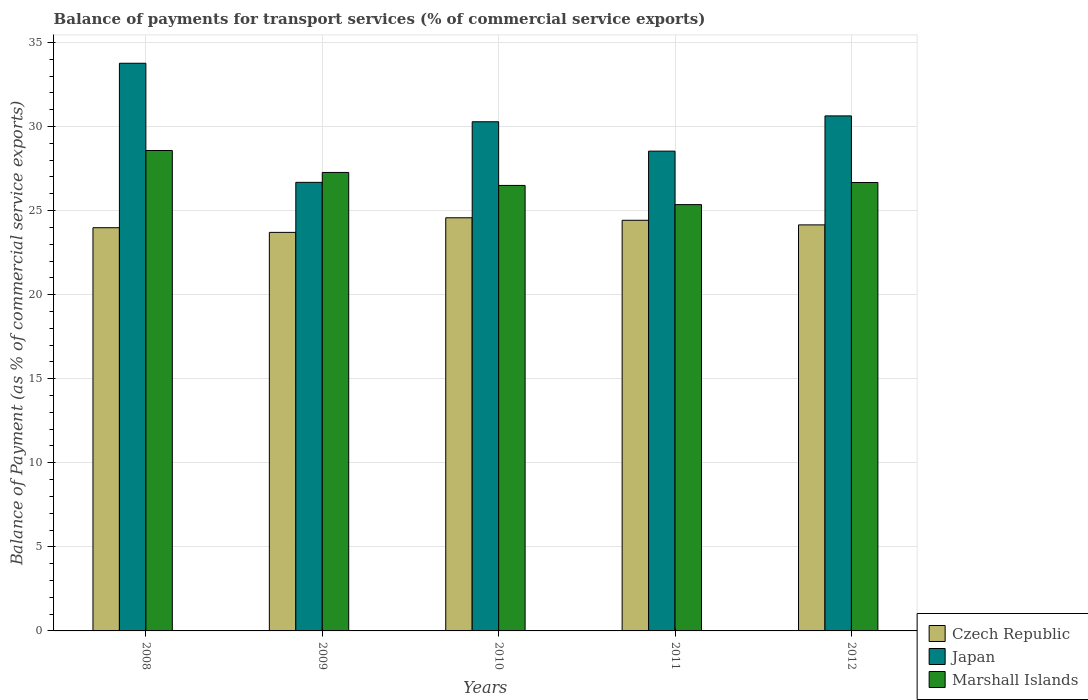How many different coloured bars are there?
Offer a terse response. 3. Are the number of bars per tick equal to the number of legend labels?
Offer a very short reply. Yes. How many bars are there on the 4th tick from the left?
Keep it short and to the point. 3. In how many cases, is the number of bars for a given year not equal to the number of legend labels?
Provide a succinct answer. 0. What is the balance of payments for transport services in Czech Republic in 2011?
Offer a terse response. 24.42. Across all years, what is the maximum balance of payments for transport services in Japan?
Keep it short and to the point. 33.76. Across all years, what is the minimum balance of payments for transport services in Czech Republic?
Provide a short and direct response. 23.7. In which year was the balance of payments for transport services in Marshall Islands maximum?
Offer a terse response. 2008. What is the total balance of payments for transport services in Marshall Islands in the graph?
Your answer should be very brief. 134.36. What is the difference between the balance of payments for transport services in Japan in 2008 and that in 2012?
Keep it short and to the point. 3.13. What is the difference between the balance of payments for transport services in Czech Republic in 2011 and the balance of payments for transport services in Marshall Islands in 2012?
Ensure brevity in your answer.  -2.25. What is the average balance of payments for transport services in Czech Republic per year?
Provide a succinct answer. 24.17. In the year 2010, what is the difference between the balance of payments for transport services in Japan and balance of payments for transport services in Marshall Islands?
Provide a succinct answer. 3.79. What is the ratio of the balance of payments for transport services in Japan in 2008 to that in 2010?
Make the answer very short. 1.11. Is the difference between the balance of payments for transport services in Japan in 2008 and 2011 greater than the difference between the balance of payments for transport services in Marshall Islands in 2008 and 2011?
Offer a terse response. Yes. What is the difference between the highest and the second highest balance of payments for transport services in Japan?
Offer a terse response. 3.13. What is the difference between the highest and the lowest balance of payments for transport services in Marshall Islands?
Make the answer very short. 3.22. What does the 3rd bar from the left in 2012 represents?
Provide a succinct answer. Marshall Islands. What does the 3rd bar from the right in 2009 represents?
Provide a succinct answer. Czech Republic. Is it the case that in every year, the sum of the balance of payments for transport services in Marshall Islands and balance of payments for transport services in Japan is greater than the balance of payments for transport services in Czech Republic?
Keep it short and to the point. Yes. How many bars are there?
Give a very brief answer. 15. How are the legend labels stacked?
Your response must be concise. Vertical. What is the title of the graph?
Your answer should be very brief. Balance of payments for transport services (% of commercial service exports). Does "Turkey" appear as one of the legend labels in the graph?
Your answer should be very brief. No. What is the label or title of the X-axis?
Ensure brevity in your answer.  Years. What is the label or title of the Y-axis?
Give a very brief answer. Balance of Payment (as % of commercial service exports). What is the Balance of Payment (as % of commercial service exports) of Czech Republic in 2008?
Keep it short and to the point. 23.98. What is the Balance of Payment (as % of commercial service exports) in Japan in 2008?
Your answer should be compact. 33.76. What is the Balance of Payment (as % of commercial service exports) of Marshall Islands in 2008?
Keep it short and to the point. 28.57. What is the Balance of Payment (as % of commercial service exports) in Czech Republic in 2009?
Your response must be concise. 23.7. What is the Balance of Payment (as % of commercial service exports) in Japan in 2009?
Make the answer very short. 26.68. What is the Balance of Payment (as % of commercial service exports) in Marshall Islands in 2009?
Give a very brief answer. 27.27. What is the Balance of Payment (as % of commercial service exports) of Czech Republic in 2010?
Keep it short and to the point. 24.57. What is the Balance of Payment (as % of commercial service exports) of Japan in 2010?
Make the answer very short. 30.28. What is the Balance of Payment (as % of commercial service exports) of Marshall Islands in 2010?
Offer a very short reply. 26.5. What is the Balance of Payment (as % of commercial service exports) in Czech Republic in 2011?
Give a very brief answer. 24.42. What is the Balance of Payment (as % of commercial service exports) in Japan in 2011?
Your answer should be compact. 28.53. What is the Balance of Payment (as % of commercial service exports) of Marshall Islands in 2011?
Ensure brevity in your answer.  25.35. What is the Balance of Payment (as % of commercial service exports) in Czech Republic in 2012?
Your response must be concise. 24.15. What is the Balance of Payment (as % of commercial service exports) in Japan in 2012?
Give a very brief answer. 30.63. What is the Balance of Payment (as % of commercial service exports) of Marshall Islands in 2012?
Offer a very short reply. 26.67. Across all years, what is the maximum Balance of Payment (as % of commercial service exports) in Czech Republic?
Your response must be concise. 24.57. Across all years, what is the maximum Balance of Payment (as % of commercial service exports) in Japan?
Provide a succinct answer. 33.76. Across all years, what is the maximum Balance of Payment (as % of commercial service exports) of Marshall Islands?
Offer a terse response. 28.57. Across all years, what is the minimum Balance of Payment (as % of commercial service exports) of Czech Republic?
Make the answer very short. 23.7. Across all years, what is the minimum Balance of Payment (as % of commercial service exports) in Japan?
Provide a succinct answer. 26.68. Across all years, what is the minimum Balance of Payment (as % of commercial service exports) of Marshall Islands?
Make the answer very short. 25.35. What is the total Balance of Payment (as % of commercial service exports) in Czech Republic in the graph?
Make the answer very short. 120.83. What is the total Balance of Payment (as % of commercial service exports) in Japan in the graph?
Provide a short and direct response. 149.89. What is the total Balance of Payment (as % of commercial service exports) in Marshall Islands in the graph?
Make the answer very short. 134.36. What is the difference between the Balance of Payment (as % of commercial service exports) of Czech Republic in 2008 and that in 2009?
Provide a short and direct response. 0.28. What is the difference between the Balance of Payment (as % of commercial service exports) in Japan in 2008 and that in 2009?
Your response must be concise. 7.08. What is the difference between the Balance of Payment (as % of commercial service exports) of Marshall Islands in 2008 and that in 2009?
Give a very brief answer. 1.31. What is the difference between the Balance of Payment (as % of commercial service exports) of Czech Republic in 2008 and that in 2010?
Provide a succinct answer. -0.59. What is the difference between the Balance of Payment (as % of commercial service exports) of Japan in 2008 and that in 2010?
Your response must be concise. 3.48. What is the difference between the Balance of Payment (as % of commercial service exports) of Marshall Islands in 2008 and that in 2010?
Provide a succinct answer. 2.08. What is the difference between the Balance of Payment (as % of commercial service exports) in Czech Republic in 2008 and that in 2011?
Provide a short and direct response. -0.44. What is the difference between the Balance of Payment (as % of commercial service exports) in Japan in 2008 and that in 2011?
Your response must be concise. 5.23. What is the difference between the Balance of Payment (as % of commercial service exports) of Marshall Islands in 2008 and that in 2011?
Provide a succinct answer. 3.22. What is the difference between the Balance of Payment (as % of commercial service exports) in Czech Republic in 2008 and that in 2012?
Give a very brief answer. -0.17. What is the difference between the Balance of Payment (as % of commercial service exports) of Japan in 2008 and that in 2012?
Offer a very short reply. 3.13. What is the difference between the Balance of Payment (as % of commercial service exports) of Marshall Islands in 2008 and that in 2012?
Make the answer very short. 1.9. What is the difference between the Balance of Payment (as % of commercial service exports) of Czech Republic in 2009 and that in 2010?
Your answer should be very brief. -0.87. What is the difference between the Balance of Payment (as % of commercial service exports) in Japan in 2009 and that in 2010?
Provide a succinct answer. -3.6. What is the difference between the Balance of Payment (as % of commercial service exports) in Marshall Islands in 2009 and that in 2010?
Your response must be concise. 0.77. What is the difference between the Balance of Payment (as % of commercial service exports) in Czech Republic in 2009 and that in 2011?
Make the answer very short. -0.72. What is the difference between the Balance of Payment (as % of commercial service exports) of Japan in 2009 and that in 2011?
Ensure brevity in your answer.  -1.86. What is the difference between the Balance of Payment (as % of commercial service exports) of Marshall Islands in 2009 and that in 2011?
Give a very brief answer. 1.91. What is the difference between the Balance of Payment (as % of commercial service exports) in Czech Republic in 2009 and that in 2012?
Provide a short and direct response. -0.45. What is the difference between the Balance of Payment (as % of commercial service exports) of Japan in 2009 and that in 2012?
Ensure brevity in your answer.  -3.95. What is the difference between the Balance of Payment (as % of commercial service exports) of Marshall Islands in 2009 and that in 2012?
Keep it short and to the point. 0.6. What is the difference between the Balance of Payment (as % of commercial service exports) in Czech Republic in 2010 and that in 2011?
Ensure brevity in your answer.  0.15. What is the difference between the Balance of Payment (as % of commercial service exports) in Japan in 2010 and that in 2011?
Ensure brevity in your answer.  1.75. What is the difference between the Balance of Payment (as % of commercial service exports) in Marshall Islands in 2010 and that in 2011?
Offer a terse response. 1.14. What is the difference between the Balance of Payment (as % of commercial service exports) in Czech Republic in 2010 and that in 2012?
Provide a short and direct response. 0.42. What is the difference between the Balance of Payment (as % of commercial service exports) of Japan in 2010 and that in 2012?
Offer a terse response. -0.35. What is the difference between the Balance of Payment (as % of commercial service exports) of Marshall Islands in 2010 and that in 2012?
Provide a succinct answer. -0.17. What is the difference between the Balance of Payment (as % of commercial service exports) of Czech Republic in 2011 and that in 2012?
Ensure brevity in your answer.  0.27. What is the difference between the Balance of Payment (as % of commercial service exports) in Japan in 2011 and that in 2012?
Make the answer very short. -2.1. What is the difference between the Balance of Payment (as % of commercial service exports) of Marshall Islands in 2011 and that in 2012?
Keep it short and to the point. -1.32. What is the difference between the Balance of Payment (as % of commercial service exports) of Czech Republic in 2008 and the Balance of Payment (as % of commercial service exports) of Japan in 2009?
Provide a succinct answer. -2.7. What is the difference between the Balance of Payment (as % of commercial service exports) of Czech Republic in 2008 and the Balance of Payment (as % of commercial service exports) of Marshall Islands in 2009?
Your answer should be compact. -3.29. What is the difference between the Balance of Payment (as % of commercial service exports) of Japan in 2008 and the Balance of Payment (as % of commercial service exports) of Marshall Islands in 2009?
Offer a very short reply. 6.49. What is the difference between the Balance of Payment (as % of commercial service exports) of Czech Republic in 2008 and the Balance of Payment (as % of commercial service exports) of Japan in 2010?
Your answer should be compact. -6.3. What is the difference between the Balance of Payment (as % of commercial service exports) in Czech Republic in 2008 and the Balance of Payment (as % of commercial service exports) in Marshall Islands in 2010?
Offer a very short reply. -2.51. What is the difference between the Balance of Payment (as % of commercial service exports) of Japan in 2008 and the Balance of Payment (as % of commercial service exports) of Marshall Islands in 2010?
Your answer should be compact. 7.27. What is the difference between the Balance of Payment (as % of commercial service exports) in Czech Republic in 2008 and the Balance of Payment (as % of commercial service exports) in Japan in 2011?
Keep it short and to the point. -4.55. What is the difference between the Balance of Payment (as % of commercial service exports) in Czech Republic in 2008 and the Balance of Payment (as % of commercial service exports) in Marshall Islands in 2011?
Ensure brevity in your answer.  -1.37. What is the difference between the Balance of Payment (as % of commercial service exports) of Japan in 2008 and the Balance of Payment (as % of commercial service exports) of Marshall Islands in 2011?
Offer a terse response. 8.41. What is the difference between the Balance of Payment (as % of commercial service exports) of Czech Republic in 2008 and the Balance of Payment (as % of commercial service exports) of Japan in 2012?
Your answer should be compact. -6.65. What is the difference between the Balance of Payment (as % of commercial service exports) of Czech Republic in 2008 and the Balance of Payment (as % of commercial service exports) of Marshall Islands in 2012?
Give a very brief answer. -2.69. What is the difference between the Balance of Payment (as % of commercial service exports) of Japan in 2008 and the Balance of Payment (as % of commercial service exports) of Marshall Islands in 2012?
Keep it short and to the point. 7.09. What is the difference between the Balance of Payment (as % of commercial service exports) in Czech Republic in 2009 and the Balance of Payment (as % of commercial service exports) in Japan in 2010?
Provide a succinct answer. -6.58. What is the difference between the Balance of Payment (as % of commercial service exports) of Czech Republic in 2009 and the Balance of Payment (as % of commercial service exports) of Marshall Islands in 2010?
Offer a very short reply. -2.79. What is the difference between the Balance of Payment (as % of commercial service exports) of Japan in 2009 and the Balance of Payment (as % of commercial service exports) of Marshall Islands in 2010?
Your answer should be very brief. 0.18. What is the difference between the Balance of Payment (as % of commercial service exports) in Czech Republic in 2009 and the Balance of Payment (as % of commercial service exports) in Japan in 2011?
Provide a succinct answer. -4.83. What is the difference between the Balance of Payment (as % of commercial service exports) in Czech Republic in 2009 and the Balance of Payment (as % of commercial service exports) in Marshall Islands in 2011?
Offer a very short reply. -1.65. What is the difference between the Balance of Payment (as % of commercial service exports) in Japan in 2009 and the Balance of Payment (as % of commercial service exports) in Marshall Islands in 2011?
Make the answer very short. 1.32. What is the difference between the Balance of Payment (as % of commercial service exports) in Czech Republic in 2009 and the Balance of Payment (as % of commercial service exports) in Japan in 2012?
Keep it short and to the point. -6.93. What is the difference between the Balance of Payment (as % of commercial service exports) in Czech Republic in 2009 and the Balance of Payment (as % of commercial service exports) in Marshall Islands in 2012?
Offer a terse response. -2.97. What is the difference between the Balance of Payment (as % of commercial service exports) in Japan in 2009 and the Balance of Payment (as % of commercial service exports) in Marshall Islands in 2012?
Give a very brief answer. 0.01. What is the difference between the Balance of Payment (as % of commercial service exports) in Czech Republic in 2010 and the Balance of Payment (as % of commercial service exports) in Japan in 2011?
Provide a succinct answer. -3.96. What is the difference between the Balance of Payment (as % of commercial service exports) in Czech Republic in 2010 and the Balance of Payment (as % of commercial service exports) in Marshall Islands in 2011?
Keep it short and to the point. -0.78. What is the difference between the Balance of Payment (as % of commercial service exports) of Japan in 2010 and the Balance of Payment (as % of commercial service exports) of Marshall Islands in 2011?
Keep it short and to the point. 4.93. What is the difference between the Balance of Payment (as % of commercial service exports) of Czech Republic in 2010 and the Balance of Payment (as % of commercial service exports) of Japan in 2012?
Provide a short and direct response. -6.06. What is the difference between the Balance of Payment (as % of commercial service exports) of Czech Republic in 2010 and the Balance of Payment (as % of commercial service exports) of Marshall Islands in 2012?
Provide a short and direct response. -2.1. What is the difference between the Balance of Payment (as % of commercial service exports) of Japan in 2010 and the Balance of Payment (as % of commercial service exports) of Marshall Islands in 2012?
Offer a very short reply. 3.61. What is the difference between the Balance of Payment (as % of commercial service exports) of Czech Republic in 2011 and the Balance of Payment (as % of commercial service exports) of Japan in 2012?
Make the answer very short. -6.21. What is the difference between the Balance of Payment (as % of commercial service exports) of Czech Republic in 2011 and the Balance of Payment (as % of commercial service exports) of Marshall Islands in 2012?
Make the answer very short. -2.25. What is the difference between the Balance of Payment (as % of commercial service exports) in Japan in 2011 and the Balance of Payment (as % of commercial service exports) in Marshall Islands in 2012?
Ensure brevity in your answer.  1.87. What is the average Balance of Payment (as % of commercial service exports) in Czech Republic per year?
Your response must be concise. 24.17. What is the average Balance of Payment (as % of commercial service exports) of Japan per year?
Give a very brief answer. 29.98. What is the average Balance of Payment (as % of commercial service exports) of Marshall Islands per year?
Your response must be concise. 26.87. In the year 2008, what is the difference between the Balance of Payment (as % of commercial service exports) of Czech Republic and Balance of Payment (as % of commercial service exports) of Japan?
Offer a terse response. -9.78. In the year 2008, what is the difference between the Balance of Payment (as % of commercial service exports) in Czech Republic and Balance of Payment (as % of commercial service exports) in Marshall Islands?
Ensure brevity in your answer.  -4.59. In the year 2008, what is the difference between the Balance of Payment (as % of commercial service exports) in Japan and Balance of Payment (as % of commercial service exports) in Marshall Islands?
Provide a succinct answer. 5.19. In the year 2009, what is the difference between the Balance of Payment (as % of commercial service exports) in Czech Republic and Balance of Payment (as % of commercial service exports) in Japan?
Make the answer very short. -2.98. In the year 2009, what is the difference between the Balance of Payment (as % of commercial service exports) of Czech Republic and Balance of Payment (as % of commercial service exports) of Marshall Islands?
Provide a succinct answer. -3.56. In the year 2009, what is the difference between the Balance of Payment (as % of commercial service exports) of Japan and Balance of Payment (as % of commercial service exports) of Marshall Islands?
Provide a short and direct response. -0.59. In the year 2010, what is the difference between the Balance of Payment (as % of commercial service exports) of Czech Republic and Balance of Payment (as % of commercial service exports) of Japan?
Your answer should be very brief. -5.71. In the year 2010, what is the difference between the Balance of Payment (as % of commercial service exports) in Czech Republic and Balance of Payment (as % of commercial service exports) in Marshall Islands?
Give a very brief answer. -1.92. In the year 2010, what is the difference between the Balance of Payment (as % of commercial service exports) in Japan and Balance of Payment (as % of commercial service exports) in Marshall Islands?
Your response must be concise. 3.79. In the year 2011, what is the difference between the Balance of Payment (as % of commercial service exports) of Czech Republic and Balance of Payment (as % of commercial service exports) of Japan?
Offer a very short reply. -4.11. In the year 2011, what is the difference between the Balance of Payment (as % of commercial service exports) in Czech Republic and Balance of Payment (as % of commercial service exports) in Marshall Islands?
Offer a very short reply. -0.93. In the year 2011, what is the difference between the Balance of Payment (as % of commercial service exports) in Japan and Balance of Payment (as % of commercial service exports) in Marshall Islands?
Offer a very short reply. 3.18. In the year 2012, what is the difference between the Balance of Payment (as % of commercial service exports) of Czech Republic and Balance of Payment (as % of commercial service exports) of Japan?
Your response must be concise. -6.48. In the year 2012, what is the difference between the Balance of Payment (as % of commercial service exports) in Czech Republic and Balance of Payment (as % of commercial service exports) in Marshall Islands?
Your answer should be very brief. -2.52. In the year 2012, what is the difference between the Balance of Payment (as % of commercial service exports) in Japan and Balance of Payment (as % of commercial service exports) in Marshall Islands?
Provide a succinct answer. 3.96. What is the ratio of the Balance of Payment (as % of commercial service exports) in Czech Republic in 2008 to that in 2009?
Keep it short and to the point. 1.01. What is the ratio of the Balance of Payment (as % of commercial service exports) of Japan in 2008 to that in 2009?
Your answer should be very brief. 1.27. What is the ratio of the Balance of Payment (as % of commercial service exports) in Marshall Islands in 2008 to that in 2009?
Make the answer very short. 1.05. What is the ratio of the Balance of Payment (as % of commercial service exports) in Czech Republic in 2008 to that in 2010?
Ensure brevity in your answer.  0.98. What is the ratio of the Balance of Payment (as % of commercial service exports) in Japan in 2008 to that in 2010?
Keep it short and to the point. 1.11. What is the ratio of the Balance of Payment (as % of commercial service exports) of Marshall Islands in 2008 to that in 2010?
Provide a short and direct response. 1.08. What is the ratio of the Balance of Payment (as % of commercial service exports) of Czech Republic in 2008 to that in 2011?
Offer a very short reply. 0.98. What is the ratio of the Balance of Payment (as % of commercial service exports) of Japan in 2008 to that in 2011?
Make the answer very short. 1.18. What is the ratio of the Balance of Payment (as % of commercial service exports) of Marshall Islands in 2008 to that in 2011?
Offer a very short reply. 1.13. What is the ratio of the Balance of Payment (as % of commercial service exports) of Czech Republic in 2008 to that in 2012?
Provide a succinct answer. 0.99. What is the ratio of the Balance of Payment (as % of commercial service exports) of Japan in 2008 to that in 2012?
Keep it short and to the point. 1.1. What is the ratio of the Balance of Payment (as % of commercial service exports) in Marshall Islands in 2008 to that in 2012?
Provide a short and direct response. 1.07. What is the ratio of the Balance of Payment (as % of commercial service exports) of Czech Republic in 2009 to that in 2010?
Your answer should be compact. 0.96. What is the ratio of the Balance of Payment (as % of commercial service exports) in Japan in 2009 to that in 2010?
Make the answer very short. 0.88. What is the ratio of the Balance of Payment (as % of commercial service exports) in Marshall Islands in 2009 to that in 2010?
Give a very brief answer. 1.03. What is the ratio of the Balance of Payment (as % of commercial service exports) in Czech Republic in 2009 to that in 2011?
Make the answer very short. 0.97. What is the ratio of the Balance of Payment (as % of commercial service exports) of Japan in 2009 to that in 2011?
Offer a very short reply. 0.93. What is the ratio of the Balance of Payment (as % of commercial service exports) of Marshall Islands in 2009 to that in 2011?
Make the answer very short. 1.08. What is the ratio of the Balance of Payment (as % of commercial service exports) of Czech Republic in 2009 to that in 2012?
Ensure brevity in your answer.  0.98. What is the ratio of the Balance of Payment (as % of commercial service exports) in Japan in 2009 to that in 2012?
Make the answer very short. 0.87. What is the ratio of the Balance of Payment (as % of commercial service exports) of Marshall Islands in 2009 to that in 2012?
Provide a succinct answer. 1.02. What is the ratio of the Balance of Payment (as % of commercial service exports) in Czech Republic in 2010 to that in 2011?
Provide a succinct answer. 1.01. What is the ratio of the Balance of Payment (as % of commercial service exports) of Japan in 2010 to that in 2011?
Ensure brevity in your answer.  1.06. What is the ratio of the Balance of Payment (as % of commercial service exports) of Marshall Islands in 2010 to that in 2011?
Your response must be concise. 1.04. What is the ratio of the Balance of Payment (as % of commercial service exports) of Czech Republic in 2010 to that in 2012?
Your response must be concise. 1.02. What is the ratio of the Balance of Payment (as % of commercial service exports) of Japan in 2010 to that in 2012?
Your answer should be compact. 0.99. What is the ratio of the Balance of Payment (as % of commercial service exports) of Marshall Islands in 2010 to that in 2012?
Your answer should be very brief. 0.99. What is the ratio of the Balance of Payment (as % of commercial service exports) in Czech Republic in 2011 to that in 2012?
Offer a terse response. 1.01. What is the ratio of the Balance of Payment (as % of commercial service exports) in Japan in 2011 to that in 2012?
Offer a very short reply. 0.93. What is the ratio of the Balance of Payment (as % of commercial service exports) of Marshall Islands in 2011 to that in 2012?
Your answer should be compact. 0.95. What is the difference between the highest and the second highest Balance of Payment (as % of commercial service exports) in Czech Republic?
Your answer should be very brief. 0.15. What is the difference between the highest and the second highest Balance of Payment (as % of commercial service exports) of Japan?
Your answer should be compact. 3.13. What is the difference between the highest and the second highest Balance of Payment (as % of commercial service exports) in Marshall Islands?
Make the answer very short. 1.31. What is the difference between the highest and the lowest Balance of Payment (as % of commercial service exports) of Czech Republic?
Provide a short and direct response. 0.87. What is the difference between the highest and the lowest Balance of Payment (as % of commercial service exports) in Japan?
Make the answer very short. 7.08. What is the difference between the highest and the lowest Balance of Payment (as % of commercial service exports) of Marshall Islands?
Offer a terse response. 3.22. 